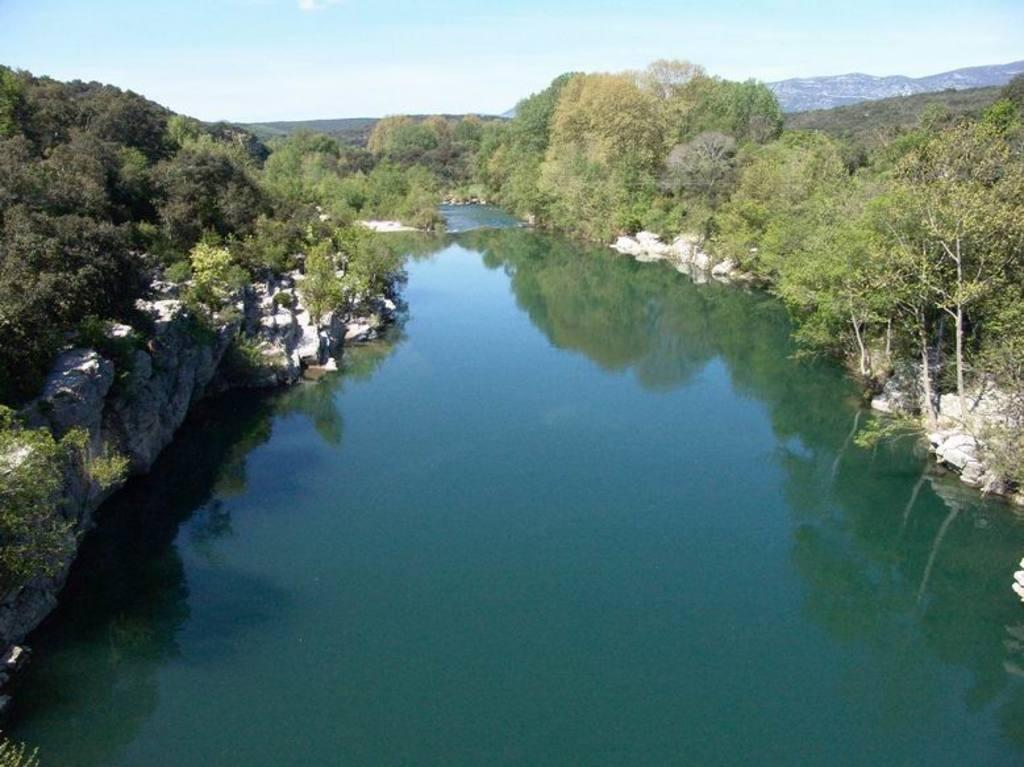What is the primary element visible in the image? There is water in the image. What other objects or features can be seen in the water? There are rocks visible in the water. What type of vegetation is present on either side of the image? Trees are present on either side of the image. What can be seen in the distance in the image? There are hills in the background of the image. What is visible above the hills in the image? The sky is visible in the background of the image. What type of advertisement can be seen on the rocks in the image? There is no advertisement present on the rocks in the image. What type of produce is growing on the trees in the image? There is no produce visible on the trees in the image; only the trees themselves are present. 